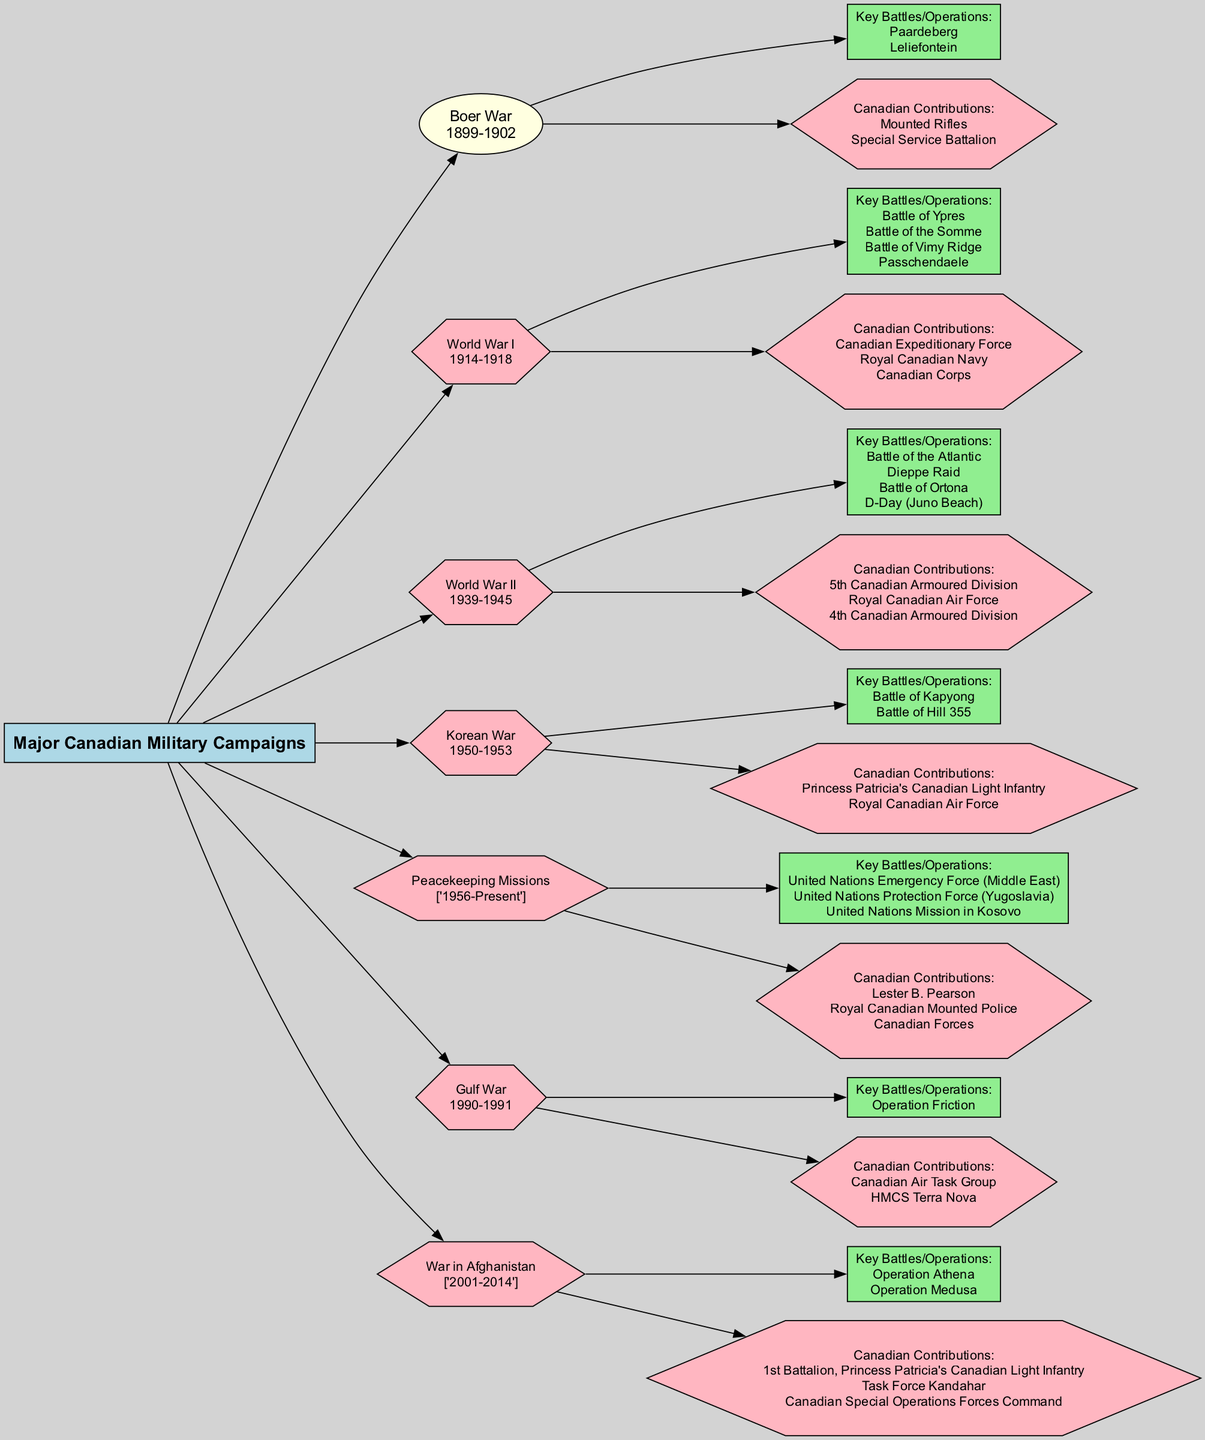What are the years of the Boer War? The diagram shows that the Boer War took place from 1899 to 1902, which is indicated in the relevant campaign node.
Answer: 1899-1902 How many key battles are listed under World War I? By examining the World War I campaign node, there are four battles listed: Battle of Ypres, Battle of the Somme, Battle of Vimy Ridge, and Passchendaele, thus counting gives four.
Answer: 4 What Canadian contribution is associated with the Gulf War? The diagram specifies that the Canadian contributions during the Gulf War included the Canadian Air Task Group and HMCS Terra Nova, which are explicitly mentioned in the Gulf War node.
Answer: Canadian Air Task Group, HMCS Terra Nova Which campaign featured the Battle of Ortona? The Battle of Ortona is listed as a key battle under World War II according to its respective campaign node.
Answer: World War II In which year did Canadian contributions to peacekeeping missions begin? The timeline for peacekeeping missions starts in 1956 as indicated in the Peacekeeping Missions node, which states the years as 1956-Present.
Answer: 1956 Which campaign has the key operation named Operation Medusa? According to the node for the War in Afghanistan, Operation Medusa is listed as one of its key operations.
Answer: War in Afghanistan How many campaigns are represented in the diagram? Counting all the distinct campaigns mentioned in the diagram yields a total of seven campaigns: Boer War, World War I, World War II, Korean War, Peacekeeping Missions, Gulf War, and War in Afghanistan.
Answer: 7 What is the main node of the diagram? The primary focus of the entire diagram is indicated in the main node titled "Major Canadian Military Campaigns," which serves as the anchor for all other nodes.
Answer: Major Canadian Military Campaigns Which campaign includes key operations related to the United Nations? The campaign related to the United Nations efforts is Peacekeeping Missions, which lists operations such as the United Nations Emergency Force (Middle East) and others.
Answer: Peacekeeping Missions 